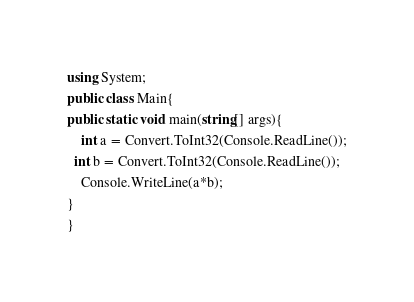<code> <loc_0><loc_0><loc_500><loc_500><_C#_>using System;
public class Main{
public static void main(string[] args){
	int a = Convert.ToInt32(Console.ReadLine());
  int b = Convert.ToInt32(Console.ReadLine());
	Console.WriteLine(a*b);
}
}
</code> 